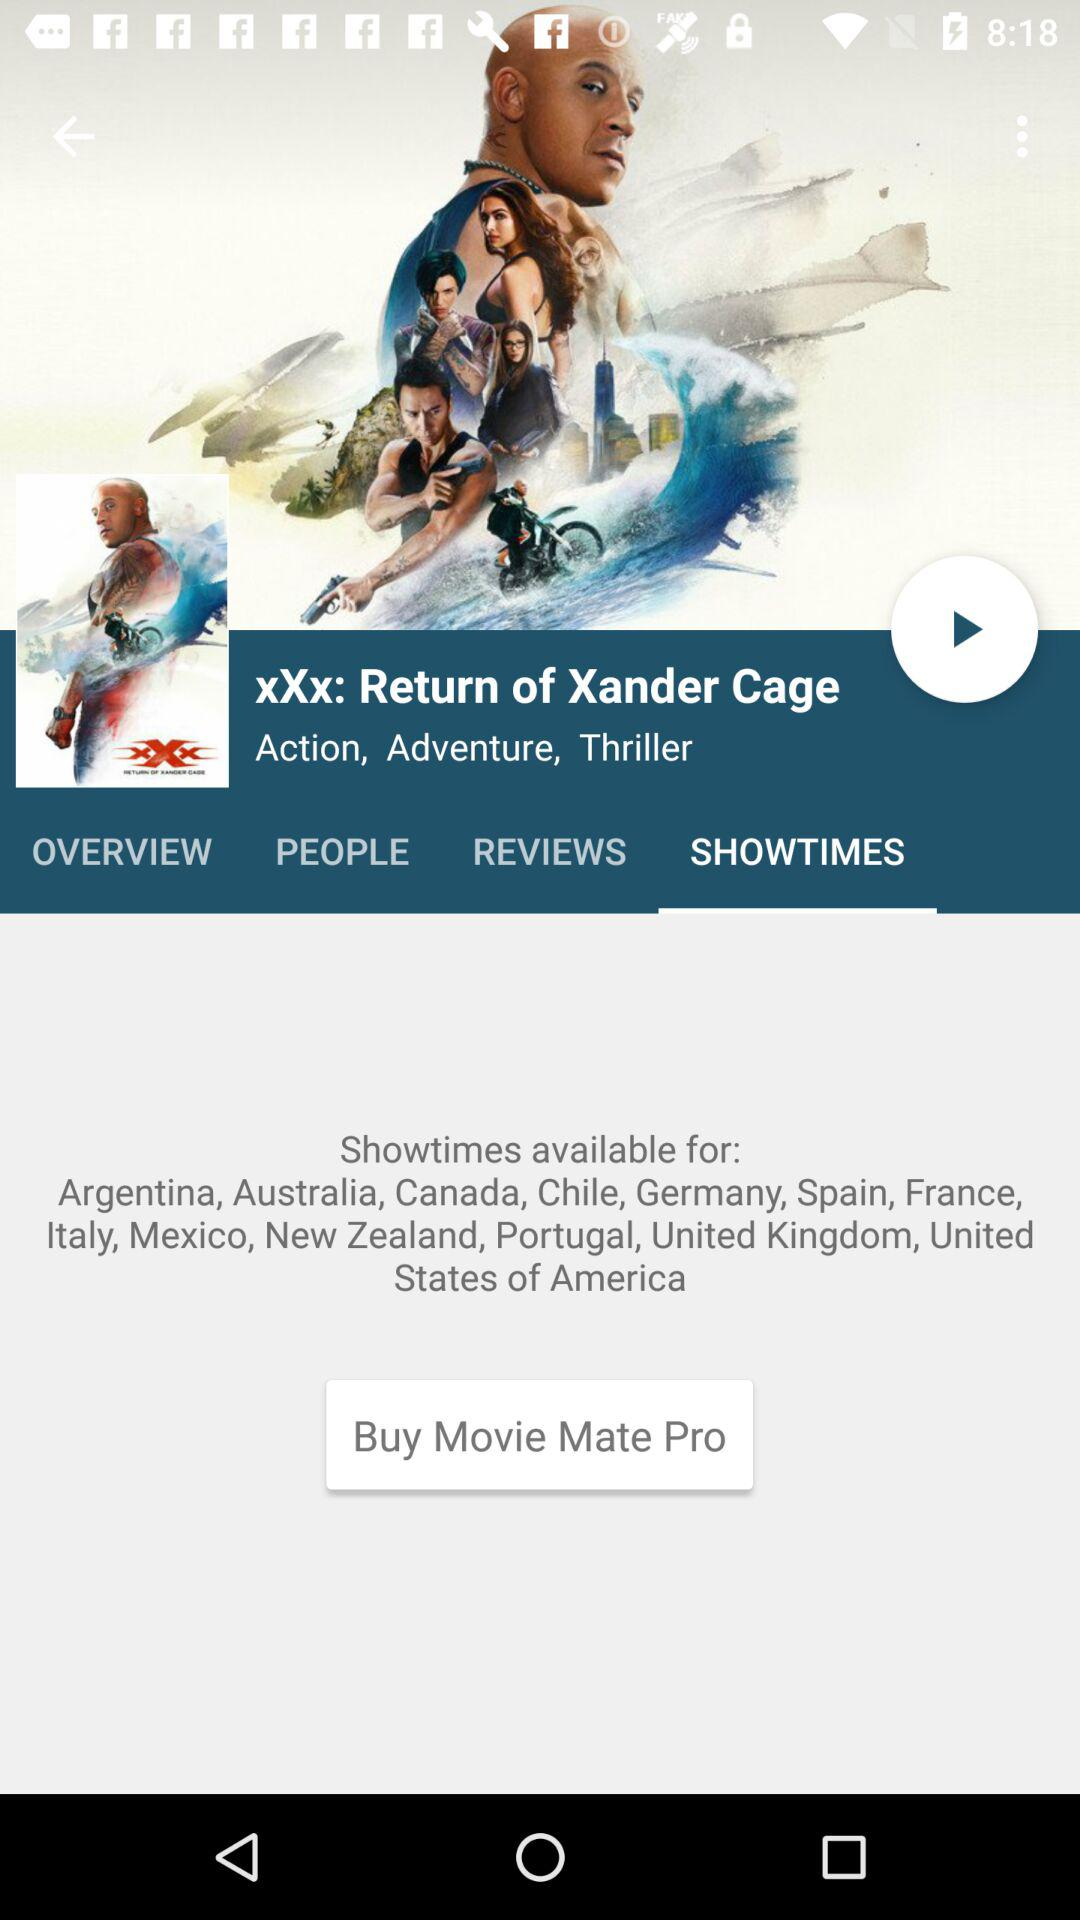What is the movie name? The name of the movie is "xXx: Return of Xander Cage". 